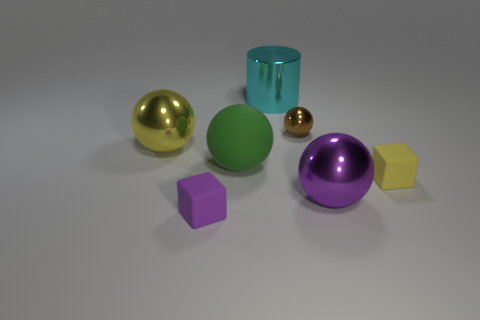What number of other objects are there of the same size as the yellow shiny object?
Ensure brevity in your answer.  3. What number of green shiny cylinders have the same size as the purple rubber object?
Your response must be concise. 0. There is a small object behind the shiny thing that is left of the large green matte ball; what is it made of?
Give a very brief answer. Metal. The tiny rubber thing to the right of the large shiny ball in front of the big metal sphere that is behind the green matte sphere is what shape?
Ensure brevity in your answer.  Cube. Do the yellow thing on the right side of the big shiny cylinder and the purple object left of the green matte sphere have the same shape?
Ensure brevity in your answer.  Yes. What number of other objects are there of the same material as the small sphere?
Your answer should be very brief. 3. The purple thing that is made of the same material as the large green object is what shape?
Offer a very short reply. Cube. Does the purple matte cube have the same size as the rubber ball?
Offer a very short reply. No. There is a yellow object on the left side of the sphere behind the big yellow shiny object; how big is it?
Keep it short and to the point. Large. What number of spheres are either cyan objects or small purple rubber objects?
Offer a terse response. 0. 